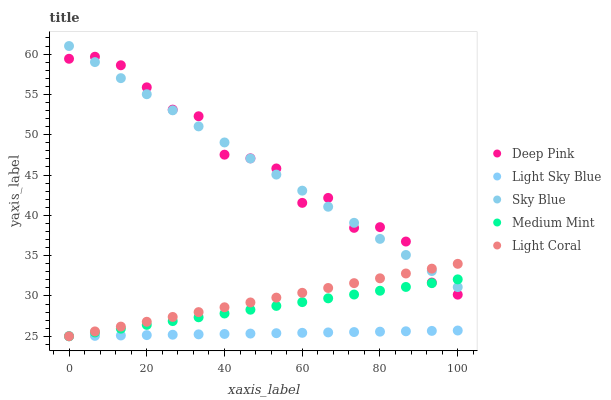Does Light Sky Blue have the minimum area under the curve?
Answer yes or no. Yes. Does Deep Pink have the maximum area under the curve?
Answer yes or no. Yes. Does Sky Blue have the minimum area under the curve?
Answer yes or no. No. Does Sky Blue have the maximum area under the curve?
Answer yes or no. No. Is Light Sky Blue the smoothest?
Answer yes or no. Yes. Is Deep Pink the roughest?
Answer yes or no. Yes. Is Sky Blue the smoothest?
Answer yes or no. No. Is Sky Blue the roughest?
Answer yes or no. No. Does Medium Mint have the lowest value?
Answer yes or no. Yes. Does Sky Blue have the lowest value?
Answer yes or no. No. Does Sky Blue have the highest value?
Answer yes or no. Yes. Does Light Coral have the highest value?
Answer yes or no. No. Is Light Sky Blue less than Deep Pink?
Answer yes or no. Yes. Is Deep Pink greater than Light Sky Blue?
Answer yes or no. Yes. Does Light Coral intersect Medium Mint?
Answer yes or no. Yes. Is Light Coral less than Medium Mint?
Answer yes or no. No. Is Light Coral greater than Medium Mint?
Answer yes or no. No. Does Light Sky Blue intersect Deep Pink?
Answer yes or no. No. 